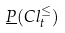Convert formula to latex. <formula><loc_0><loc_0><loc_500><loc_500>\underline { P } ( C l _ { t } ^ { \leq } )</formula> 